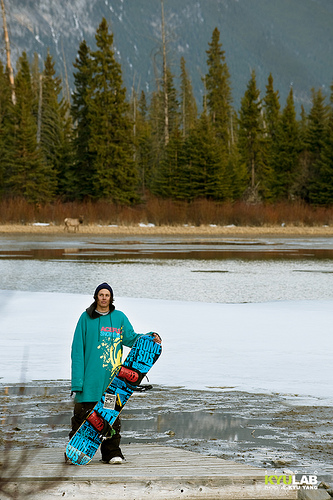Please transcribe the text information in this image. mome SDS TAXO KYU LAB 